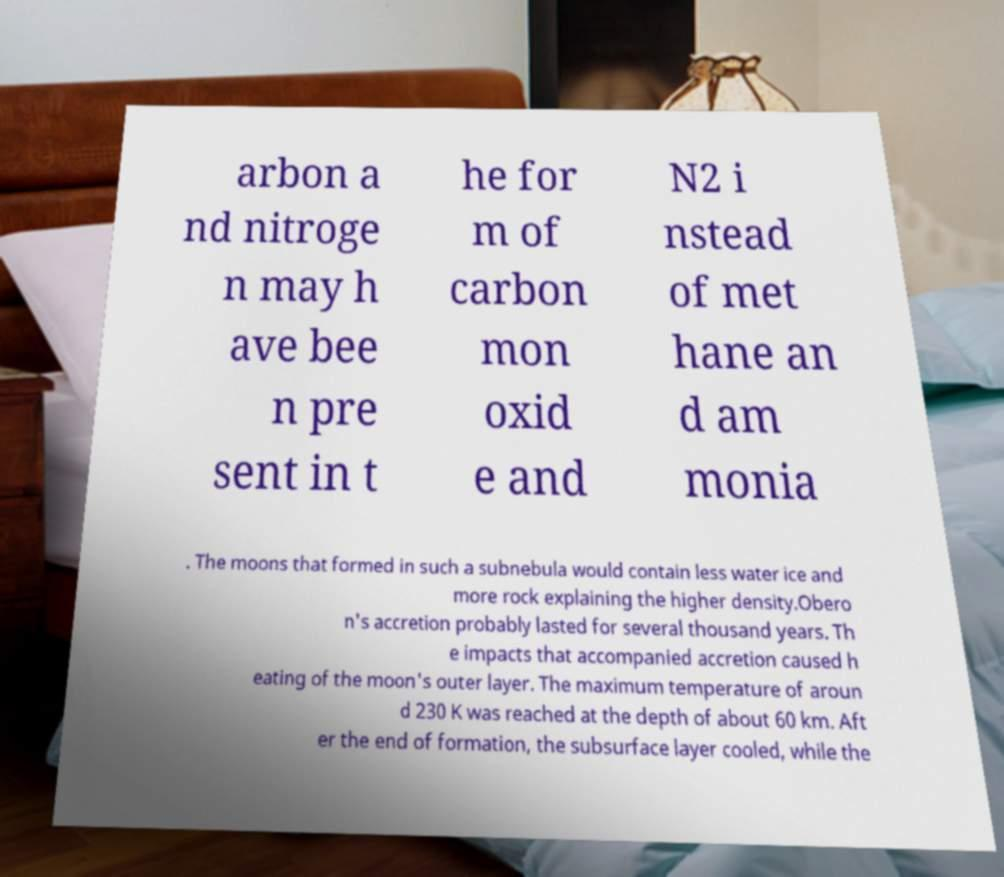Can you accurately transcribe the text from the provided image for me? arbon a nd nitroge n may h ave bee n pre sent in t he for m of carbon mon oxid e and N2 i nstead of met hane an d am monia . The moons that formed in such a subnebula would contain less water ice and more rock explaining the higher density.Obero n's accretion probably lasted for several thousand years. Th e impacts that accompanied accretion caused h eating of the moon's outer layer. The maximum temperature of aroun d 230 K was reached at the depth of about 60 km. Aft er the end of formation, the subsurface layer cooled, while the 